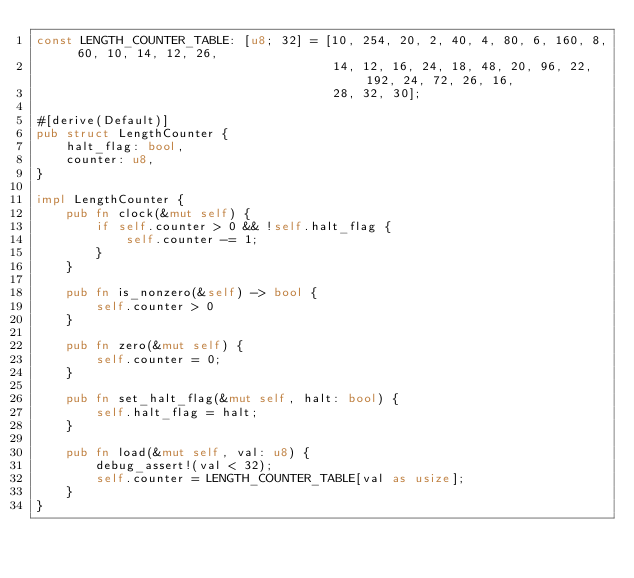Convert code to text. <code><loc_0><loc_0><loc_500><loc_500><_Rust_>const LENGTH_COUNTER_TABLE: [u8; 32] = [10, 254, 20, 2, 40, 4, 80, 6, 160, 8, 60, 10, 14, 12, 26,
                                        14, 12, 16, 24, 18, 48, 20, 96, 22, 192, 24, 72, 26, 16,
                                        28, 32, 30];

#[derive(Default)]
pub struct LengthCounter {
    halt_flag: bool,
    counter: u8,
}

impl LengthCounter {
    pub fn clock(&mut self) {
        if self.counter > 0 && !self.halt_flag {
            self.counter -= 1;
        }
    }

    pub fn is_nonzero(&self) -> bool {
        self.counter > 0
    }

    pub fn zero(&mut self) {
        self.counter = 0;
    }

    pub fn set_halt_flag(&mut self, halt: bool) {
        self.halt_flag = halt;
    }

    pub fn load(&mut self, val: u8) {
        debug_assert!(val < 32);
        self.counter = LENGTH_COUNTER_TABLE[val as usize];
    }
}
</code> 